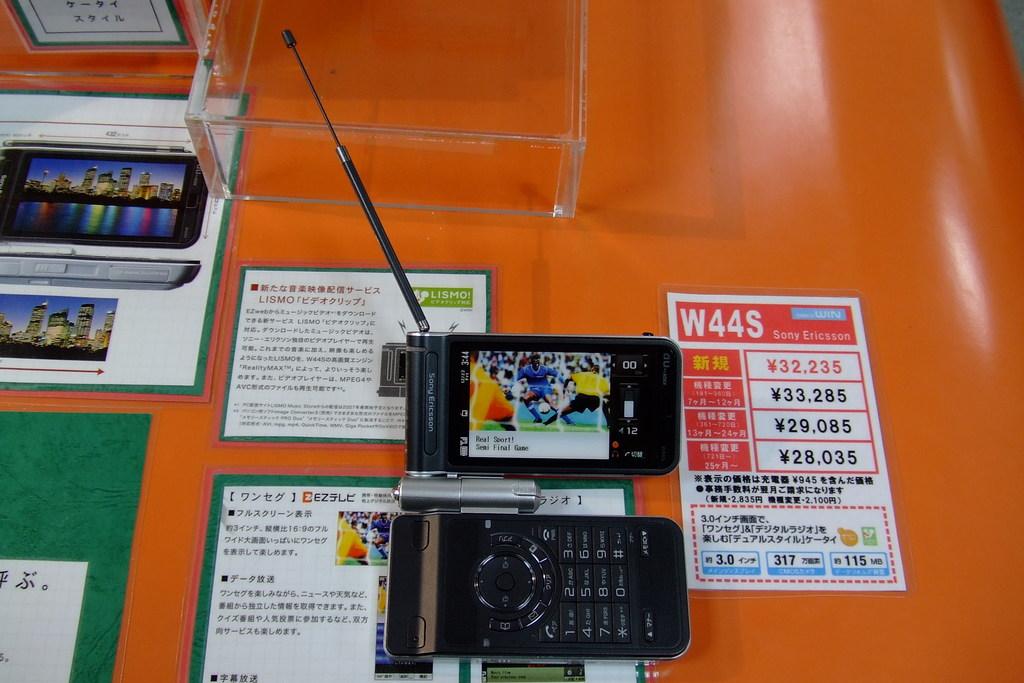What brand is on the flyer on the right?
Give a very brief answer. Sony ericsson. Boys are playing?
Provide a succinct answer. Soccer. 